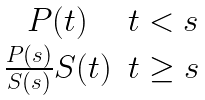Convert formula to latex. <formula><loc_0><loc_0><loc_500><loc_500>\begin{matrix} P ( t ) & t < s \\ \frac { P ( s ) } { S ( s ) } { S ( t ) } & t \geq s \end{matrix}</formula> 